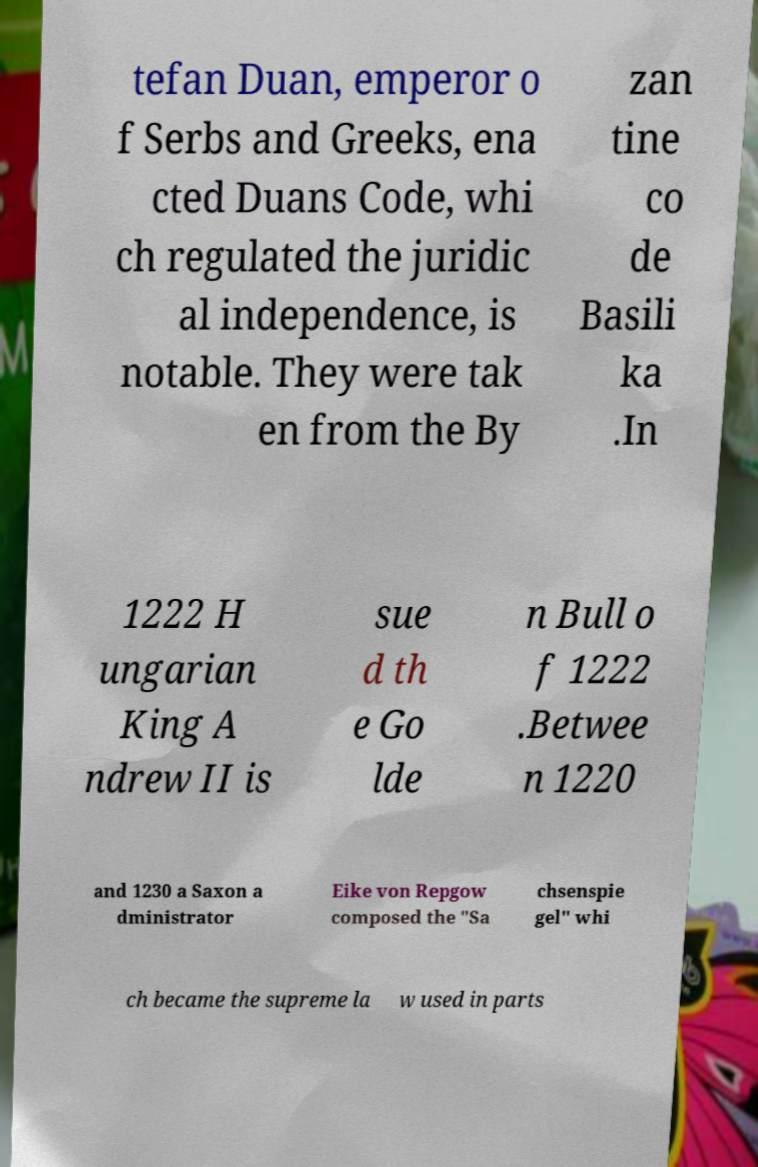Could you extract and type out the text from this image? tefan Duan, emperor o f Serbs and Greeks, ena cted Duans Code, whi ch regulated the juridic al independence, is notable. They were tak en from the By zan tine co de Basili ka .In 1222 H ungarian King A ndrew II is sue d th e Go lde n Bull o f 1222 .Betwee n 1220 and 1230 a Saxon a dministrator Eike von Repgow composed the "Sa chsenspie gel" whi ch became the supreme la w used in parts 